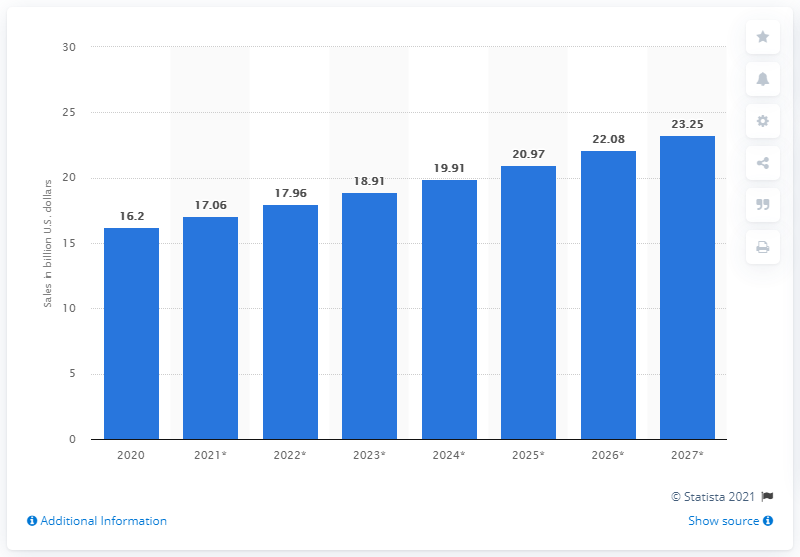Point out several critical features in this image. In 2020, the estimated size of the frozen pizza market in the U.S. was 16.2 billion dollars. The frozen pizza market is expected to reach a projected size of 23.25 by 2027. 